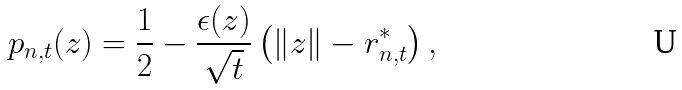<formula> <loc_0><loc_0><loc_500><loc_500>p _ { n , t } ( z ) = \frac { 1 } { 2 } - \frac { \epsilon ( z ) } { \sqrt { t } } \left ( \| z \| - r _ { n , t } ^ { * } \right ) ,</formula> 